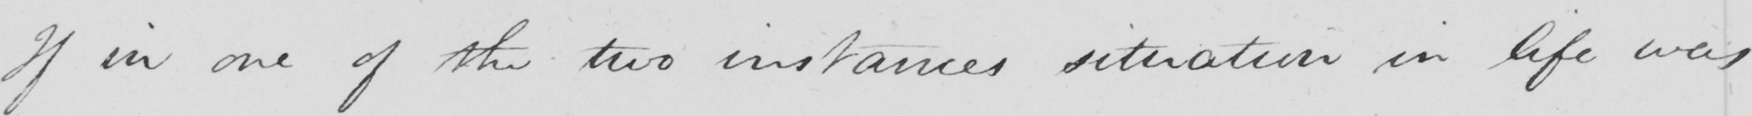What does this handwritten line say? If in one of the two instances situation in life was 